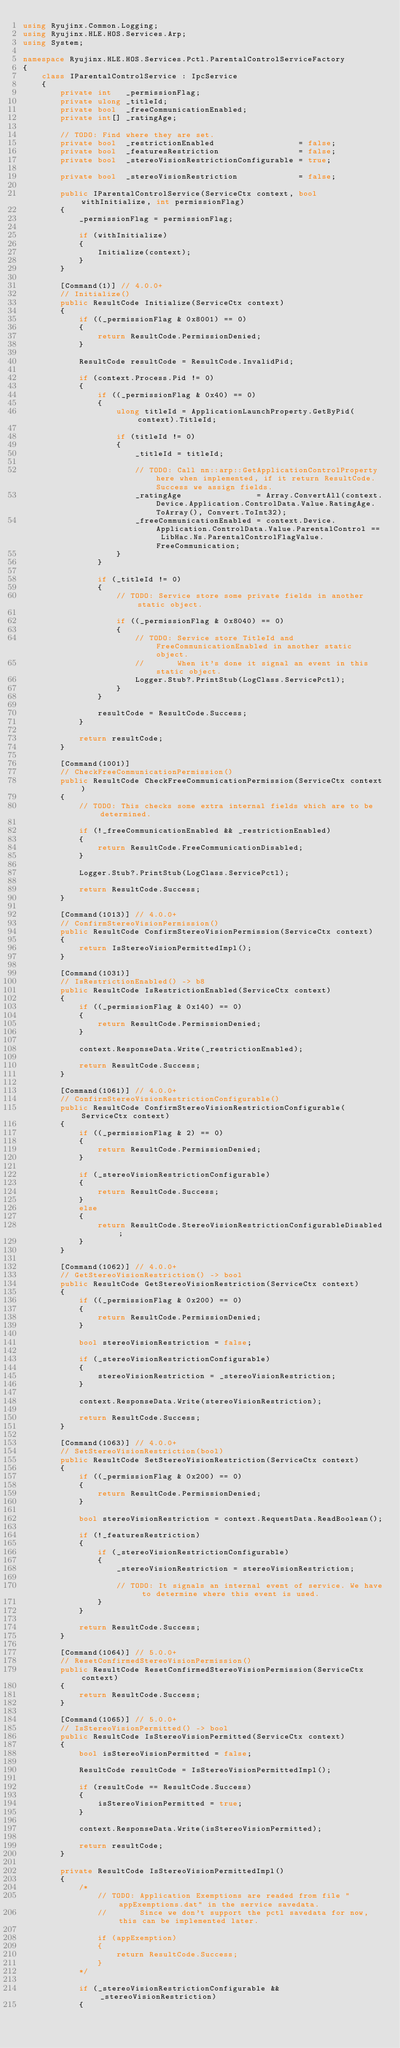<code> <loc_0><loc_0><loc_500><loc_500><_C#_>using Ryujinx.Common.Logging;
using Ryujinx.HLE.HOS.Services.Arp;
using System;

namespace Ryujinx.HLE.HOS.Services.Pctl.ParentalControlServiceFactory
{
    class IParentalControlService : IpcService
    {
        private int   _permissionFlag;
        private ulong _titleId;
        private bool  _freeCommunicationEnabled;
        private int[] _ratingAge;

        // TODO: Find where they are set.
        private bool  _restrictionEnabled                  = false;
        private bool  _featuresRestriction                 = false;
        private bool  _stereoVisionRestrictionConfigurable = true;

        private bool  _stereoVisionRestriction             = false;

        public IParentalControlService(ServiceCtx context, bool withInitialize, int permissionFlag)
        {
            _permissionFlag = permissionFlag;

            if (withInitialize)
            {
                Initialize(context);
            }
        }

        [Command(1)] // 4.0.0+
        // Initialize()
        public ResultCode Initialize(ServiceCtx context)
        {
            if ((_permissionFlag & 0x8001) == 0)
            {
                return ResultCode.PermissionDenied;
            }

            ResultCode resultCode = ResultCode.InvalidPid;

            if (context.Process.Pid != 0)
            {
                if ((_permissionFlag & 0x40) == 0)
                {
                    ulong titleId = ApplicationLaunchProperty.GetByPid(context).TitleId;

                    if (titleId != 0)
                    {
                        _titleId = titleId;

                        // TODO: Call nn::arp::GetApplicationControlProperty here when implemented, if it return ResultCode.Success we assign fields.
                        _ratingAge                = Array.ConvertAll(context.Device.Application.ControlData.Value.RatingAge.ToArray(), Convert.ToInt32);
                        _freeCommunicationEnabled = context.Device.Application.ControlData.Value.ParentalControl == LibHac.Ns.ParentalControlFlagValue.FreeCommunication;
                    }
                }

                if (_titleId != 0)
                {
                    // TODO: Service store some private fields in another static object.

                    if ((_permissionFlag & 0x8040) == 0)
                    {
                        // TODO: Service store TitleId and FreeCommunicationEnabled in another static object.
                        //       When it's done it signal an event in this static object.
                        Logger.Stub?.PrintStub(LogClass.ServicePctl);
                    }
                }

                resultCode = ResultCode.Success;
            }

            return resultCode;
        }

        [Command(1001)]
        // CheckFreeCommunicationPermission()
        public ResultCode CheckFreeCommunicationPermission(ServiceCtx context)
        {
            // TODO: This checks some extra internal fields which are to be determined.

            if (!_freeCommunicationEnabled && _restrictionEnabled)
            {
                return ResultCode.FreeCommunicationDisabled;
            }

            Logger.Stub?.PrintStub(LogClass.ServicePctl);

            return ResultCode.Success;
        }

        [Command(1013)] // 4.0.0+
        // ConfirmStereoVisionPermission()
        public ResultCode ConfirmStereoVisionPermission(ServiceCtx context)
        {
            return IsStereoVisionPermittedImpl();
        }

        [Command(1031)]
        // IsRestrictionEnabled() -> b8
        public ResultCode IsRestrictionEnabled(ServiceCtx context)
        {
            if ((_permissionFlag & 0x140) == 0)
            {
                return ResultCode.PermissionDenied;
            }

            context.ResponseData.Write(_restrictionEnabled);

            return ResultCode.Success;
        }

        [Command(1061)] // 4.0.0+
        // ConfirmStereoVisionRestrictionConfigurable()
        public ResultCode ConfirmStereoVisionRestrictionConfigurable(ServiceCtx context)
        {
            if ((_permissionFlag & 2) == 0)
            {
                return ResultCode.PermissionDenied;
            }

            if (_stereoVisionRestrictionConfigurable)
            {
                return ResultCode.Success;
            }
            else
            {
                return ResultCode.StereoVisionRestrictionConfigurableDisabled;
            }
        }

        [Command(1062)] // 4.0.0+
        // GetStereoVisionRestriction() -> bool
        public ResultCode GetStereoVisionRestriction(ServiceCtx context)
        {
            if ((_permissionFlag & 0x200) == 0)
            {
                return ResultCode.PermissionDenied;
            }

            bool stereoVisionRestriction = false;

            if (_stereoVisionRestrictionConfigurable)
            {
                stereoVisionRestriction = _stereoVisionRestriction;
            }

            context.ResponseData.Write(stereoVisionRestriction);

            return ResultCode.Success;
        }

        [Command(1063)] // 4.0.0+
        // SetStereoVisionRestriction(bool)
        public ResultCode SetStereoVisionRestriction(ServiceCtx context)
        {
            if ((_permissionFlag & 0x200) == 0)
            {
                return ResultCode.PermissionDenied;
            }

            bool stereoVisionRestriction = context.RequestData.ReadBoolean();

            if (!_featuresRestriction)
            {
                if (_stereoVisionRestrictionConfigurable)
                {
                    _stereoVisionRestriction = stereoVisionRestriction;

                    // TODO: It signals an internal event of service. We have to determine where this event is used. 
                }
            }

            return ResultCode.Success;
        }

        [Command(1064)] // 5.0.0+
        // ResetConfirmedStereoVisionPermission()
        public ResultCode ResetConfirmedStereoVisionPermission(ServiceCtx context)
        {
            return ResultCode.Success;
        }

        [Command(1065)] // 5.0.0+
        // IsStereoVisionPermitted() -> bool
        public ResultCode IsStereoVisionPermitted(ServiceCtx context)
        {
            bool isStereoVisionPermitted = false;

            ResultCode resultCode = IsStereoVisionPermittedImpl();

            if (resultCode == ResultCode.Success)
            {
                isStereoVisionPermitted = true;
            }

            context.ResponseData.Write(isStereoVisionPermitted);

            return resultCode;
        }

        private ResultCode IsStereoVisionPermittedImpl()
        {
            /*
                // TODO: Application Exemptions are readed from file "appExemptions.dat" in the service savedata.
                //       Since we don't support the pctl savedata for now, this can be implemented later.

                if (appExemption)
                {
                    return ResultCode.Success;
                }
            */

            if (_stereoVisionRestrictionConfigurable && _stereoVisionRestriction)
            {</code> 